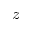Convert formula to latex. <formula><loc_0><loc_0><loc_500><loc_500>z</formula> 